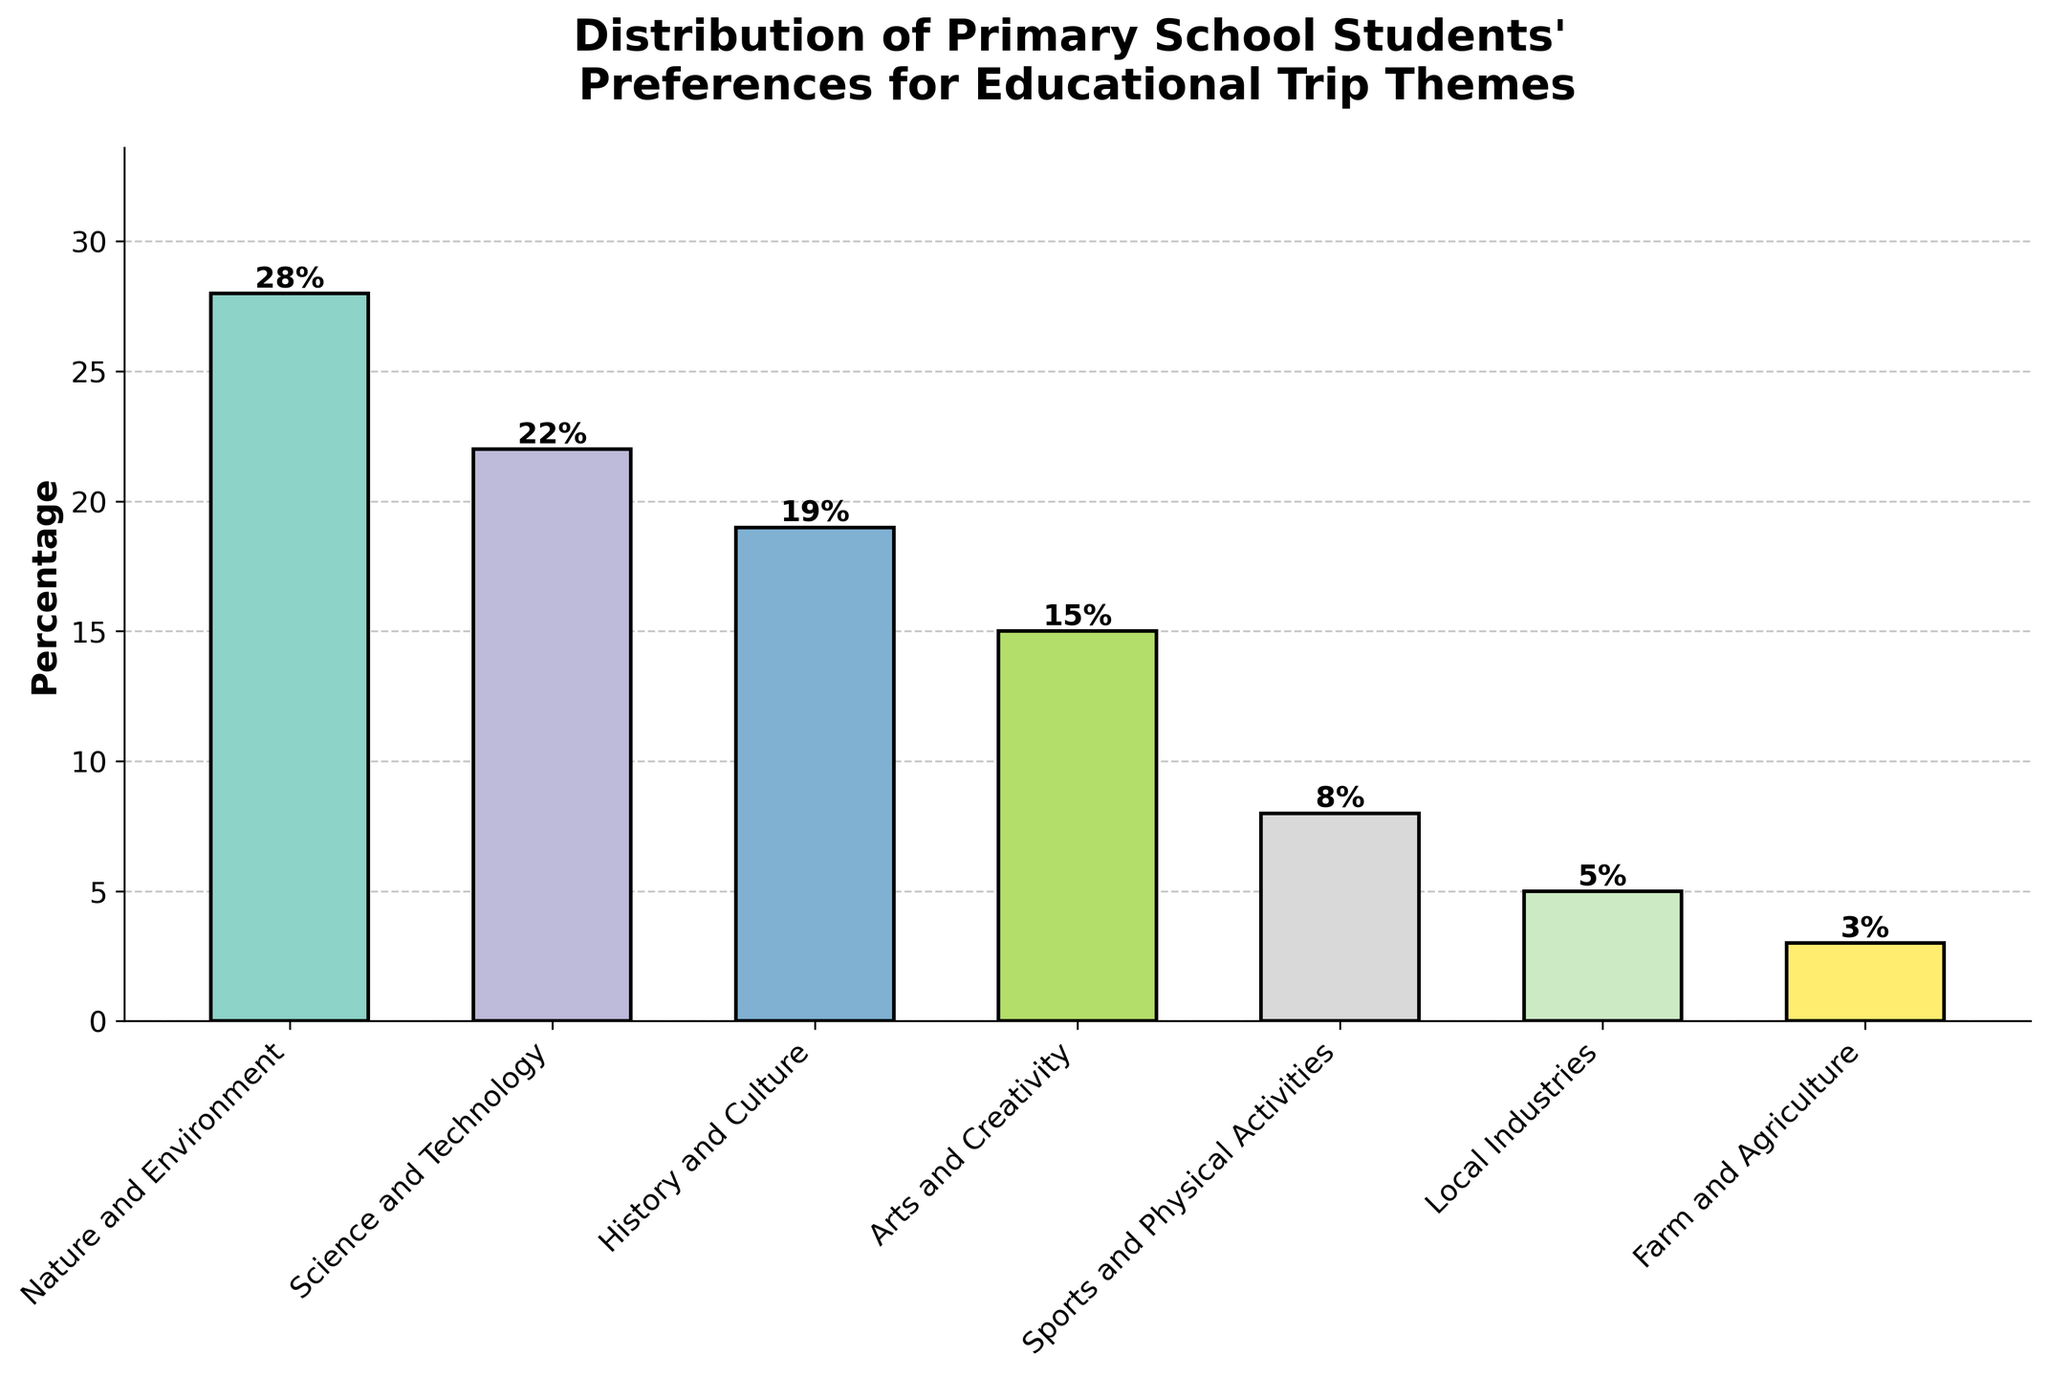Which theme is the most popular among the primary school students? The theme with the highest bar represents the most popular theme. From the figure, Nature and Environment has the highest bar, at 28%.
Answer: Nature and Environment Which theme is the least popular among the primary school students? The theme with the shortest bar represents the least popular theme. From the figure, Farm and Agriculture has the shortest bar, at 3%.
Answer: Farm and Agriculture How much more popular is Nature and Environment than Sports and Physical Activities? Subtract the percentage of Sports and Physical Activities from Nature and Environment. That is 28% - 8% = 20%.
Answer: 20% Which two themes have a combined preference closest to Science and Technology? Sum the percentages of different combinations of themes and find the pair closest to 22%. History and Culture (19%) + Sports and Physical Activities (8%) = 27%, Arts and Creativity (15%) + Local Industries (5%) = 20%, Farm and Agriculture (3%) + History and Culture (19%) = 22%. The pair Farm and Agriculture and History and Culture sum exactly to 22%.
Answer: Farm and Agriculture, History and Culture How many themes have a preference percentage above 20%? Count the bars higher than 20% on the figure. Nature and Environment (28%) and Science and Technology (22%) are the two themes above 20%.
Answer: 2 What is the combined preference percentage of the three least popular themes? Add the percentages of the three shortest bars. Farm and Agriculture (3%) + Local Industries (5%) + Sports and Physical Activities (8%) = 16%.
Answer: 16% By how much does the preference for Science and Technology exceed that for Arts and Creativity? Subtract the percentage of Arts and Creativity from Science and Technology. That is 22% - 15% = 7%.
Answer: 7% What is the average preference percentage for all the educational trip themes? Sum all percentages and divide by the number of themes. (28 + 22 + 19 + 15 + 8 + 5 + 3) / 7 = 100 / 7 ≈ 14.29%.
Answer: 14.29% Which theme has the second highest preference among the students? The second highest bar represents the second highest preference. Science and Technology (22%) is just below Nature and Environment.
Answer: Science and Technology How much higher is the preference for History and Culture compared to Local Industries? Subtract the percentage of Local Industries from History and Culture. That is 19% - 5% = 14%.
Answer: 14% 